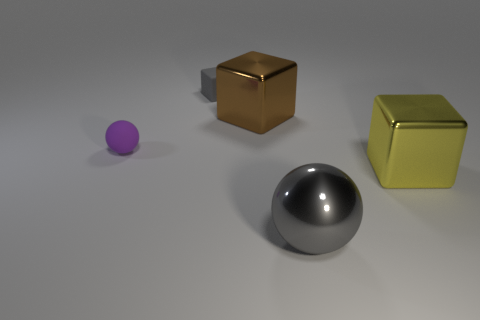What is the material of the other small thing that is the same shape as the brown metallic object?
Your answer should be very brief. Rubber. Is the big cube behind the large yellow thing made of the same material as the small gray block?
Ensure brevity in your answer.  No. Is the number of shiny balls left of the big gray metal object greater than the number of matte spheres that are behind the big brown object?
Your response must be concise. No. What is the size of the gray metal thing?
Provide a succinct answer. Large. There is a tiny object that is the same material as the small cube; what is its shape?
Provide a short and direct response. Sphere. Does the matte thing in front of the small gray rubber block have the same shape as the large yellow thing?
Your answer should be compact. No. How many things are either big gray things or gray shiny cubes?
Give a very brief answer. 1. The thing that is both on the left side of the brown shiny block and on the right side of the purple thing is made of what material?
Keep it short and to the point. Rubber. Do the yellow object and the gray matte thing have the same size?
Provide a short and direct response. No. There is a sphere that is to the left of the metal cube behind the rubber sphere; how big is it?
Offer a terse response. Small. 